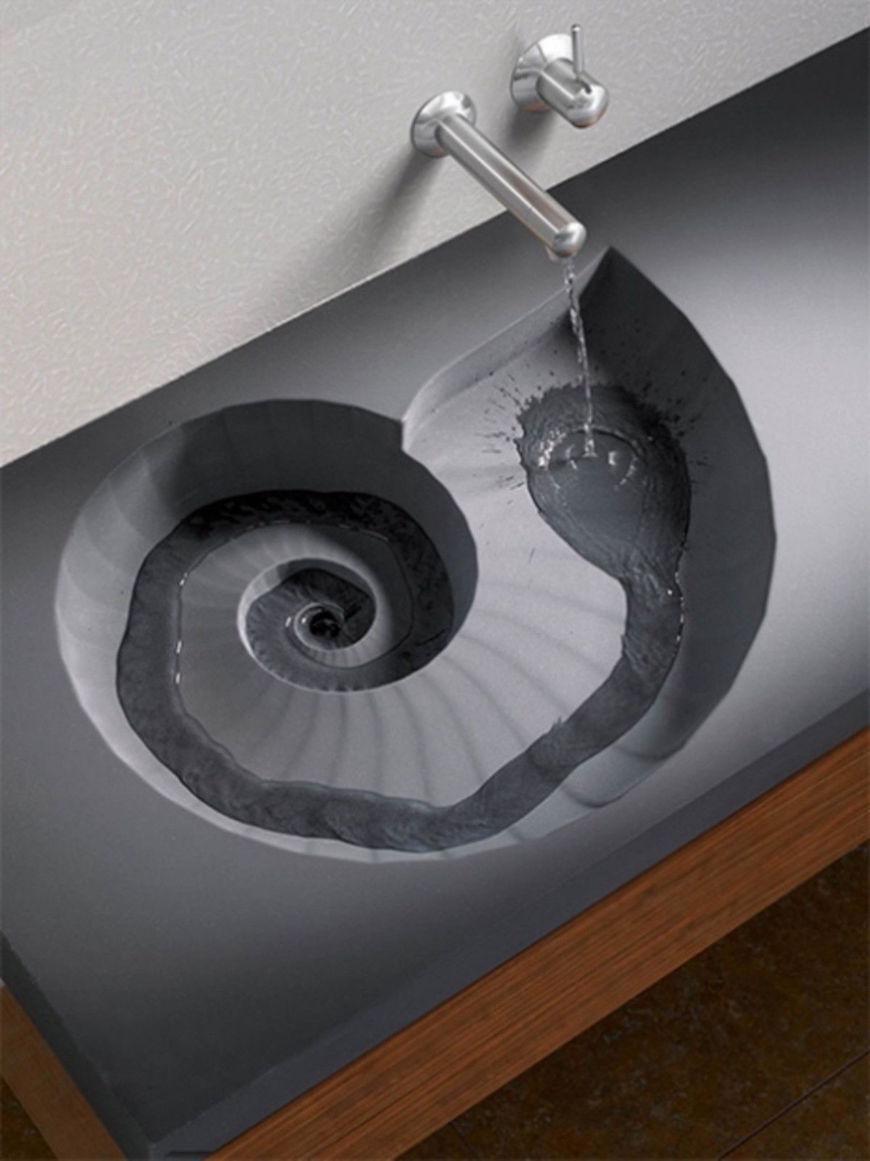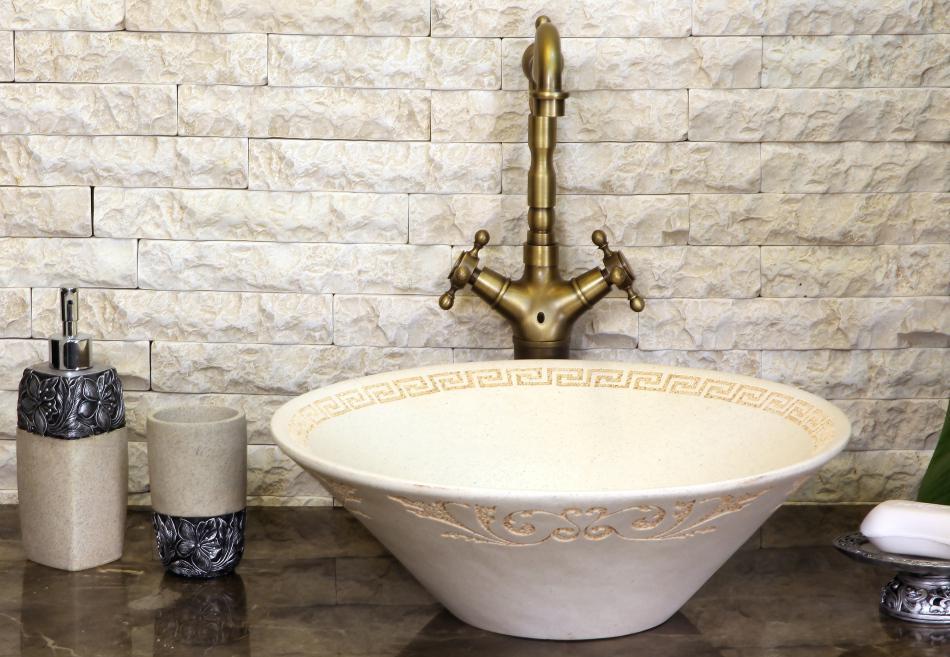The first image is the image on the left, the second image is the image on the right. Assess this claim about the two images: "The sink in the right image is a bowl sitting on a counter.". Correct or not? Answer yes or no. Yes. The first image is the image on the left, the second image is the image on the right. For the images shown, is this caption "Both images in the pair show sinks and one of them is seashell themed." true? Answer yes or no. Yes. 